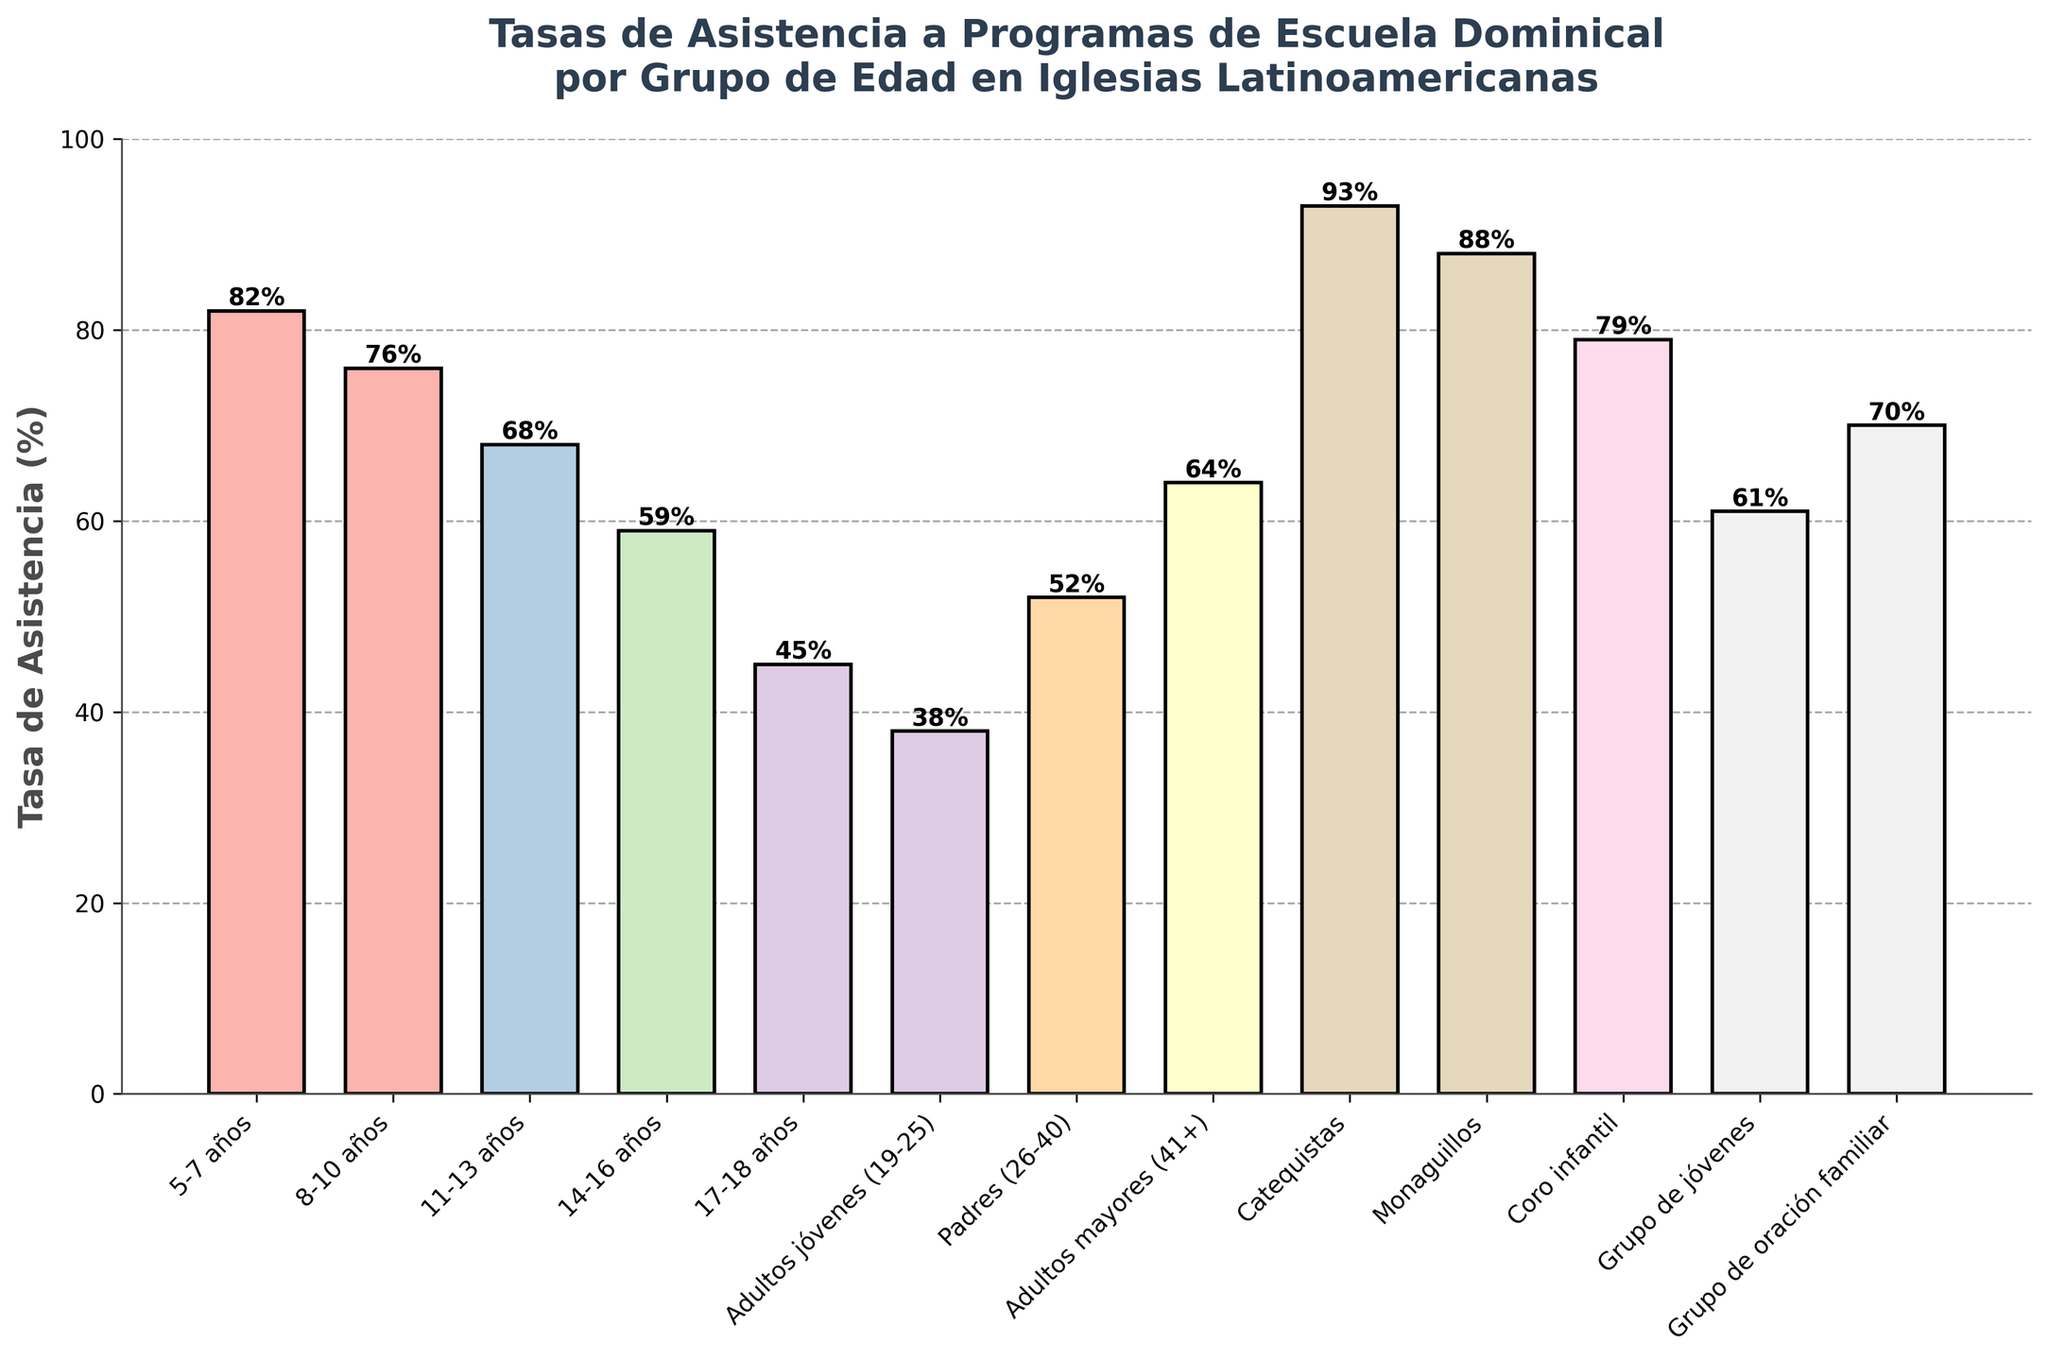¿Qué grupo de edad tiene la tasa de asistencia más alta? Al observar las alturas de las barras, la barra más alta representa a los Catequistas.
Answer: Catequistas ¿Cuál es la diferencia en la tasa de asistencia entre los Monaguillos y los jóvenes de 17-18 años? La tasa de asistencia de los Monaguillos es 88% y la de los jóvenes de 17-18 años es 45%. La diferencia es 88% - 45% = 43%.
Answer: 43% ¿Cuál es el promedio de la tasa de asistencia de los grupos 5-7 años, 8-10 años y 11-13 años? Sumamos las tasas de asistencia: 82 + 76 + 68 = 226. Luego, dividimos por 3 para obtener el promedio: 226 / 3 ≈ 75.33%.
Answer: 75.33% ¿Cuál es la relación entre la tasa de asistencia de los Adultos jóvenes (19-25) y los Padres (26-40)? La tasa de asistencia de los Adultos jóvenes es 38%, mientras que la de los Padres es 52%. Los Padres tienen una tasa de asistencia mayor.
Answer: Padres ¿Cuál es el rango de las tasas de asistencia mostradas en el gráfico? La tasa de asistencia más baja es 38% (Adultos jóvenes) y la más alta es 93% (Catequistas). El rango es 93% - 38% = 55%.
Answer: 55% ¿Cuál sería la asistencia total si sumamos las tasas de asistencia de los Monaguillos y el Coro infantil? La tasa de asistencia de los Monaguillos es 88% y la del Coro infantil es 79%. Sumamos ambas tasas: 88 + 79 = 167%.
Answer: 167% Compara las tasas de asistencia de los Catequistas y el Grupo de oración familiar. ¿Cuál es la diferencia absolutal? Los Catequistas tienen una tasa de asistencia de 93% y el Grupo de oración familiar de 70%. La diferencia es 93% - 70% = 23%.
Answer: 23% ¿Cuál es la mediana de las tasas de asistencia dadas (excluyendo grupos específicos como Catequistas y Monaguillos)? Ordenamos las tasas de asistencia excluyendo a Catequistas (93%) y Monaguillos (88%): 38%, 45%, 52%, 59%, 61%, 64%, 68%, 70%, 76%, 79%, 82%. La mediana (el valor central) es 64%.
Answer: 64% 